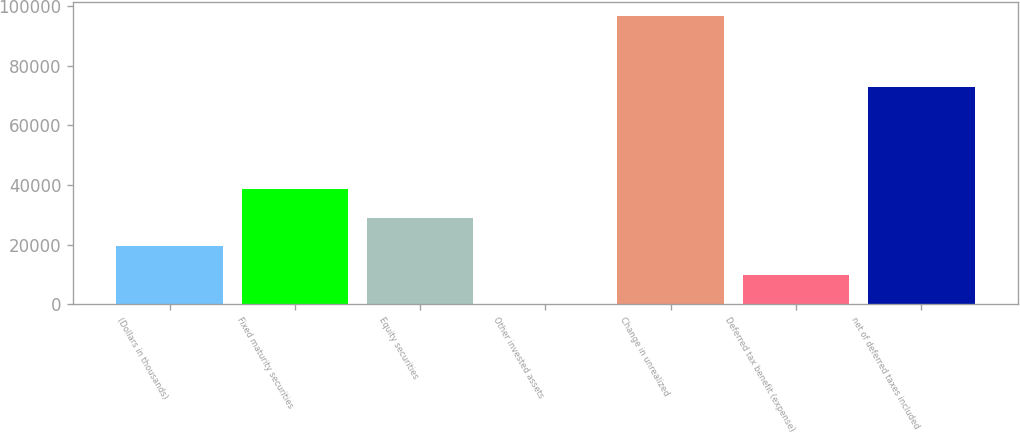Convert chart to OTSL. <chart><loc_0><loc_0><loc_500><loc_500><bar_chart><fcel>(Dollars in thousands)<fcel>Fixed maturity securities<fcel>Equity securities<fcel>Other invested assets<fcel>Change in unrealized<fcel>Deferred tax benefit (expense)<fcel>net of deferred taxes included<nl><fcel>19370.2<fcel>38680.4<fcel>29025.3<fcel>60<fcel>96611<fcel>9715.1<fcel>72747<nl></chart> 